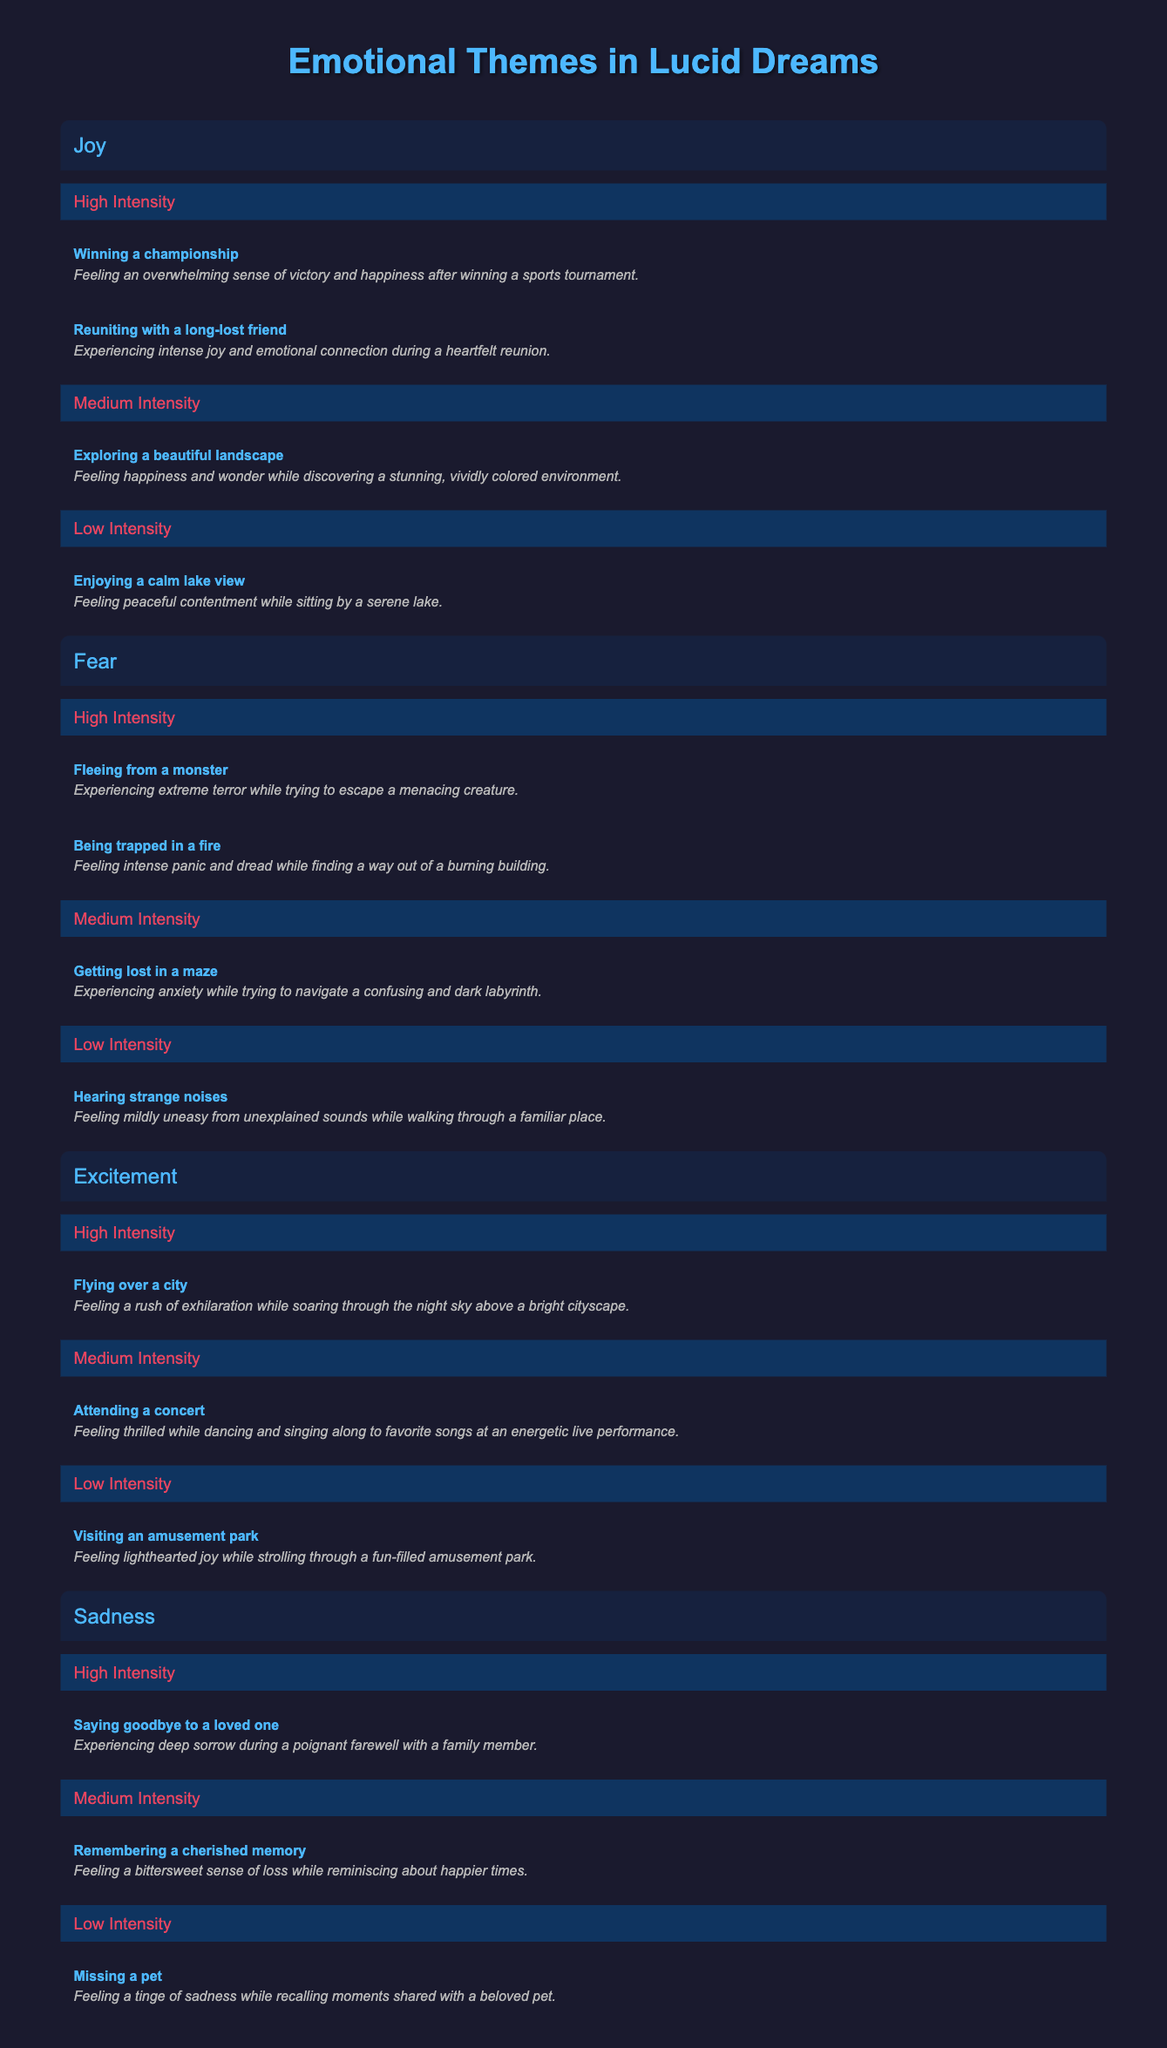What are the dream scenarios listed under High Intensity for the emotion of Fear? According to the table, the High Intensity dream scenarios under Fear are "Fleeing from a monster" and "Being trapped in a fire."
Answer: Fleeing from a monster, Being trapped in a fire Which emotional theme has the least number of dream scenarios at High Intensity? The emotional theme of Sadness has only one dream scenario listed at High Intensity, which is "Saying goodbye to a loved one," while other themes have two.
Answer: Sadness How many dream scenarios are classified as Low Intensity across all emotional themes? There are three emotional themes (Joy, Fear, Excitement, and Sadness), and each has one Low Intensity dream scenario. Therefore, the total count is 1 + 1 + 1 + 1 = 4.
Answer: 4 Is there a dream scenario in the excitement category that matches a low intensity description? Yes, the scenario "Visiting an amusement park" is categorized under Low Intensity for Excitement, indicating a lighthearted joy experience.
Answer: Yes What is the average number of High Intensity dream scenarios across all emotional themes? There are four different emotional themes with the following counts for High Intensity scenarios: Joy (2), Fear (2), Excitement (1), Sadness (1). Thus, the average is (2 + 2 + 1 + 1) / 4 = 1.5.
Answer: 1.5 